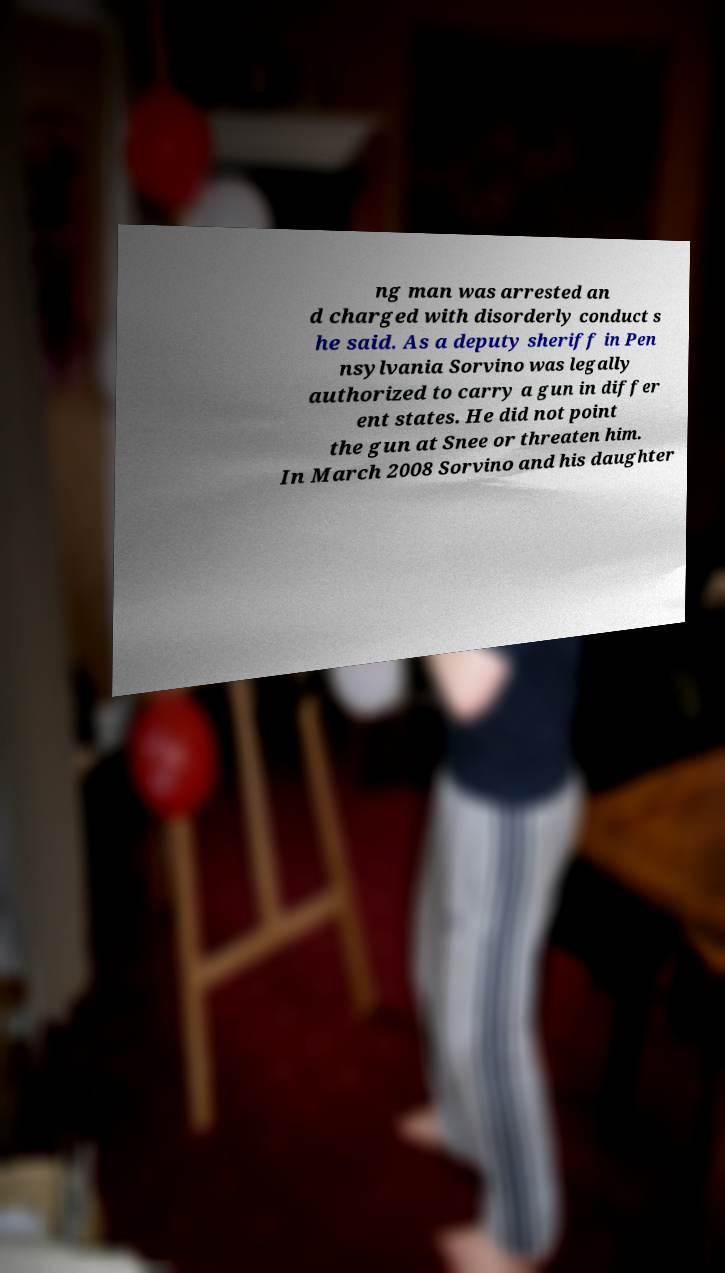What messages or text are displayed in this image? I need them in a readable, typed format. ng man was arrested an d charged with disorderly conduct s he said. As a deputy sheriff in Pen nsylvania Sorvino was legally authorized to carry a gun in differ ent states. He did not point the gun at Snee or threaten him. In March 2008 Sorvino and his daughter 